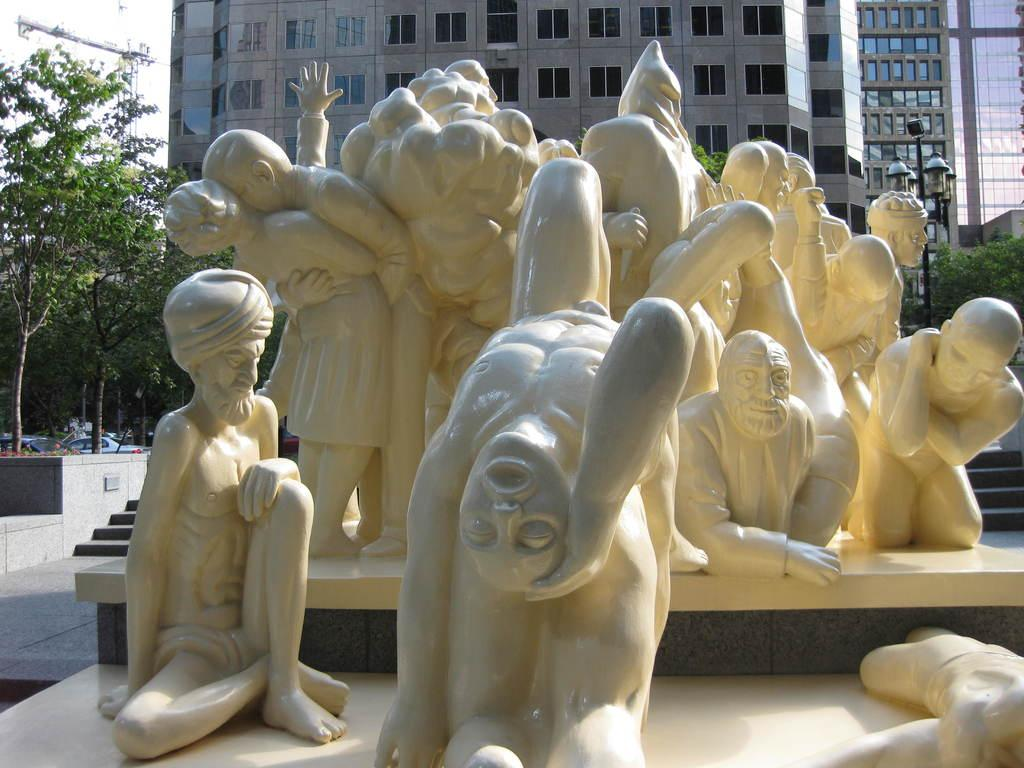What type of objects are in the middle of the image? There are statues of humans in the image. What color are the statues? The statues are in white color. Where are the statues located in relation to the image? The statues are in the middle of the image. What can be seen in the background of the image? There are trees and a building in the background of the image. What type of tail can be seen on the statues in the image? There are no tails present on the statues in the image, as they are statues of humans. What invention is being demonstrated by the statues in the image? The statues in the image are not demonstrating any invention; they are simply statues of humans. 